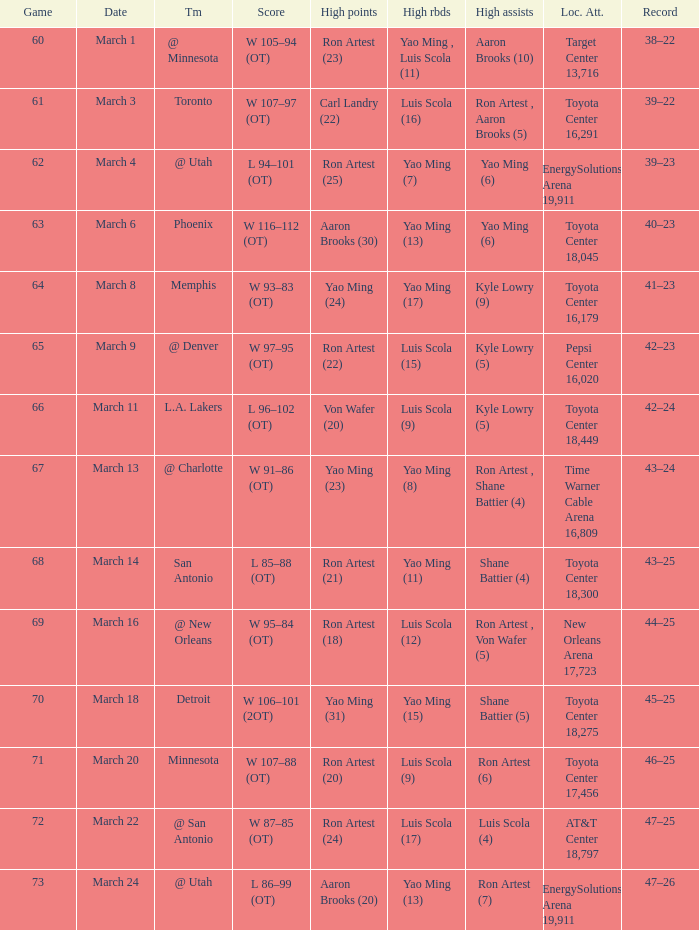On what date did the Rockets play Memphis? March 8. 